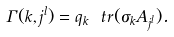<formula> <loc_0><loc_0><loc_500><loc_500>\Gamma ( k , j ^ { l } ) = q _ { k } \ t r ( \sigma _ { k } A _ { j ^ { l } } ) .</formula> 